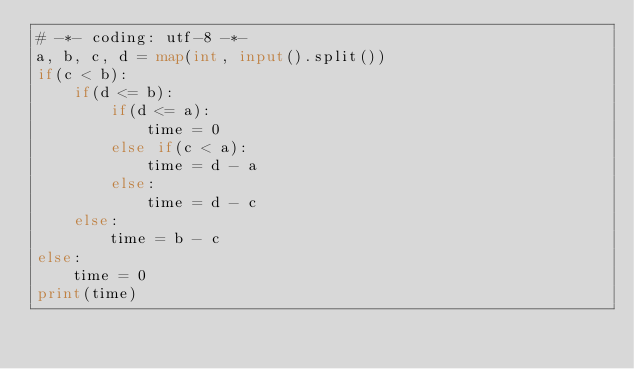Convert code to text. <code><loc_0><loc_0><loc_500><loc_500><_Python_># -*- coding: utf-8 -*-
a, b, c, d = map(int, input().split())
if(c < b):
    if(d <= b):
        if(d <= a):
            time = 0
        else if(c < a):
            time = d - a
        else:
            time = d - c
    else:
        time = b - c
else:
    time = 0
print(time)
</code> 